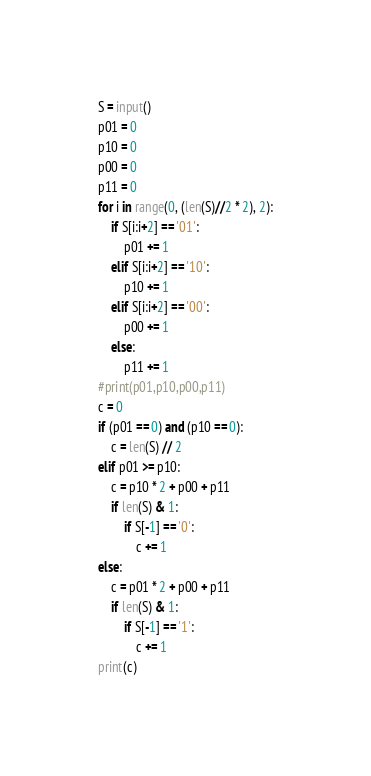Convert code to text. <code><loc_0><loc_0><loc_500><loc_500><_Python_>S = input()
p01 = 0
p10 = 0
p00 = 0
p11 = 0
for i in range(0, (len(S)//2 * 2), 2):
    if S[i:i+2] == '01':
        p01 += 1
    elif S[i:i+2] == '10':
        p10 += 1
    elif S[i:i+2] == '00':
        p00 += 1
    else:
        p11 += 1
#print(p01,p10,p00,p11)
c = 0
if (p01 == 0) and (p10 == 0):
    c = len(S) // 2
elif p01 >= p10:
    c = p10 * 2 + p00 + p11
    if len(S) & 1:
        if S[-1] == '0':
            c += 1
else:
    c = p01 * 2 + p00 + p11
    if len(S) & 1:
        if S[-1] == '1':
            c += 1
print(c)</code> 